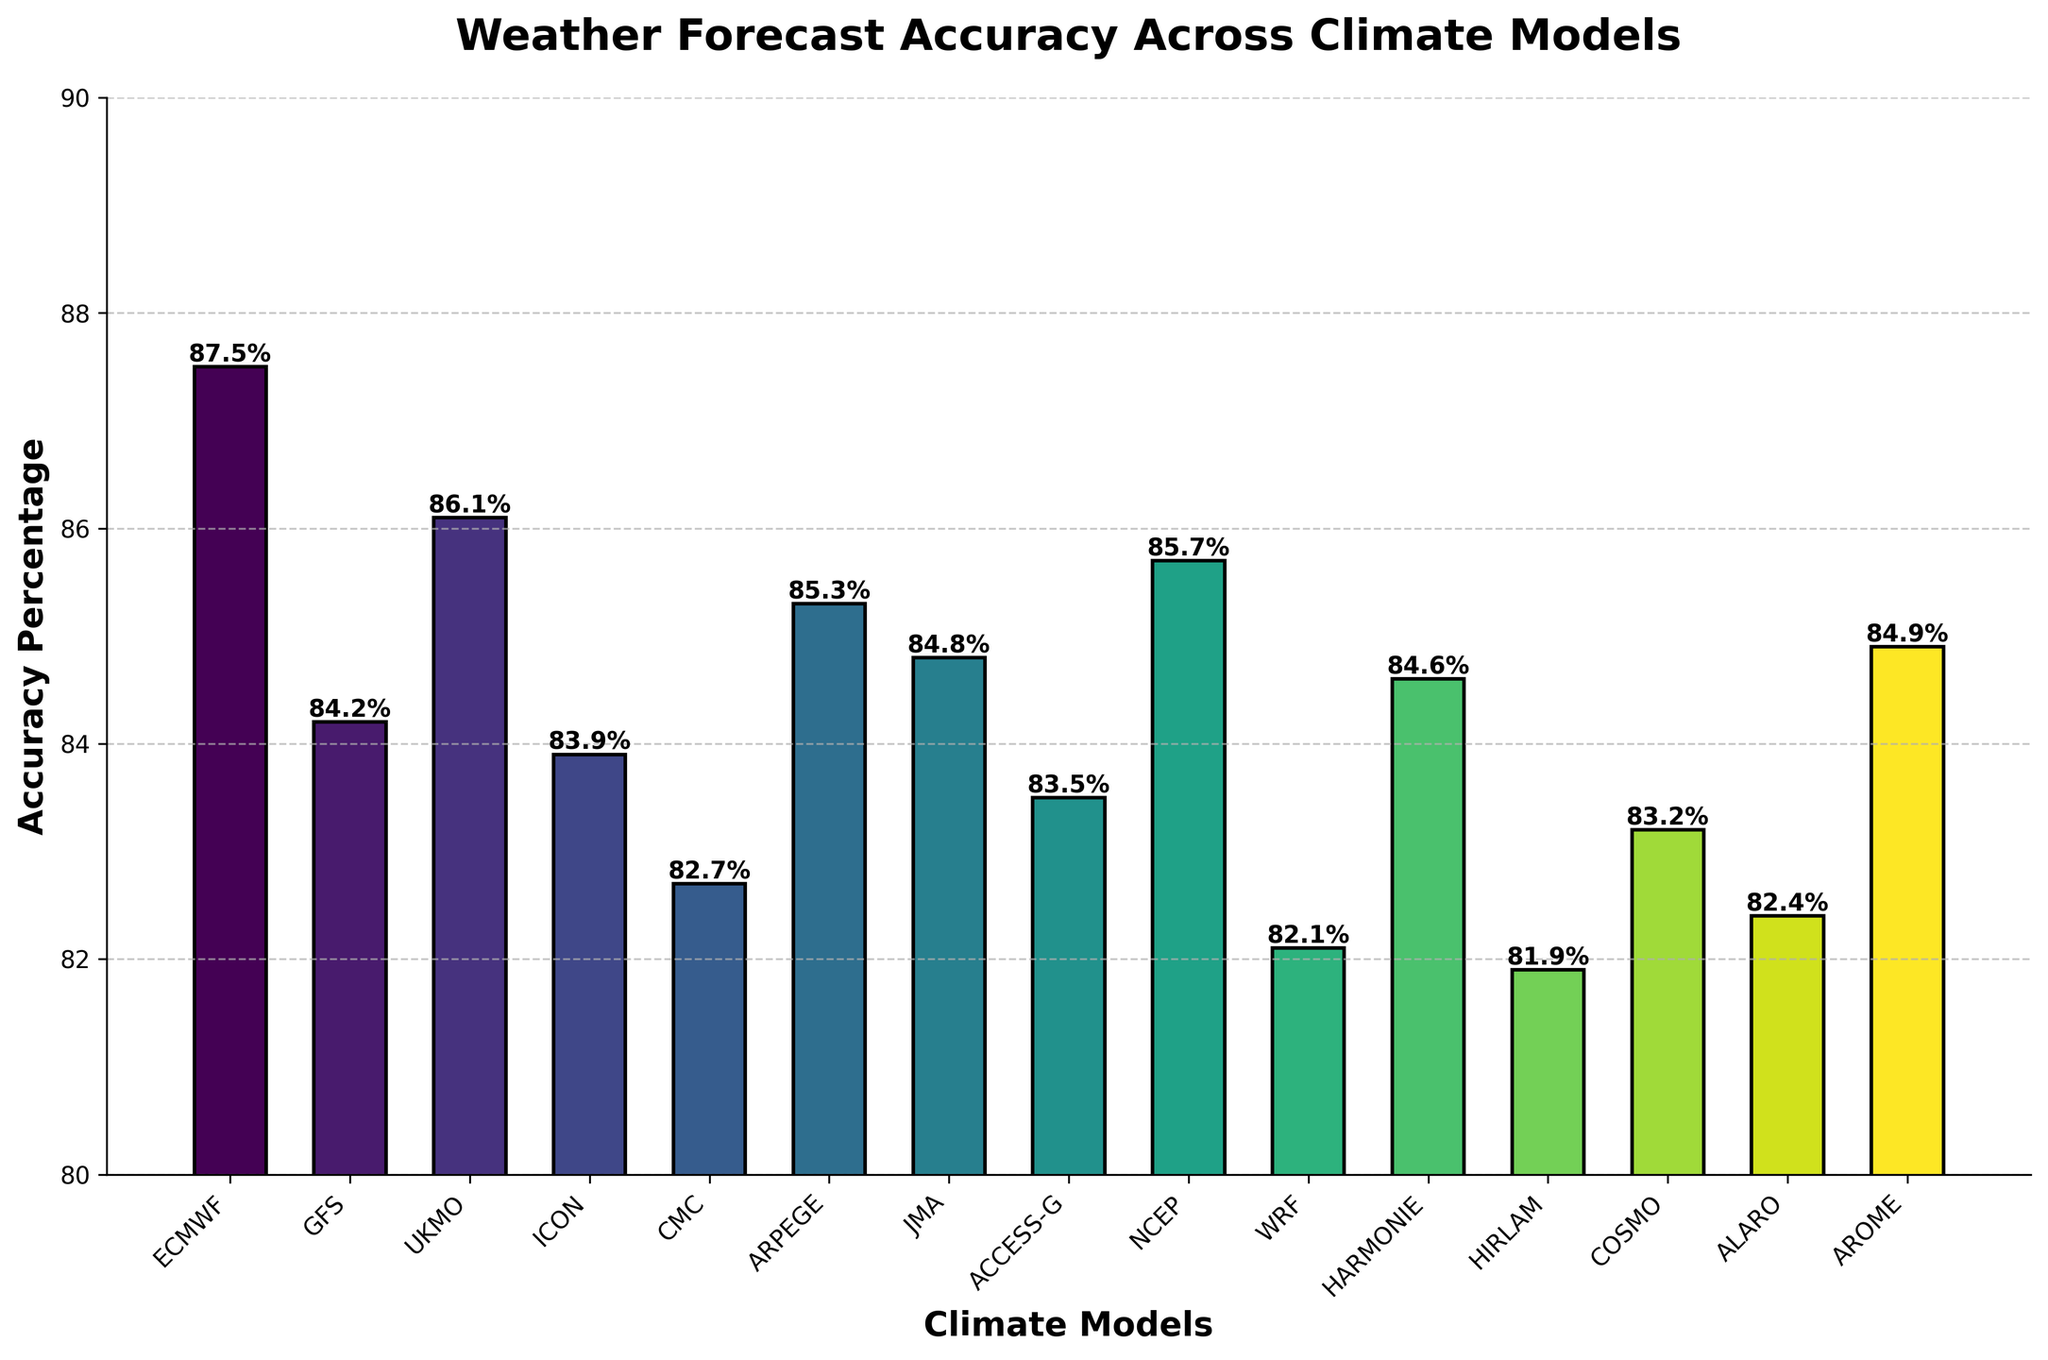Which climate model has the highest weather forecast accuracy? Identify the bar that reaches the highest point in the chart which represents the highest accuracy percentage. That model is ECMWF with 87.5%.
Answer: ECMWF Is the forecast accuracy of GFS higher or lower than ARPEGE? Compare the heights of the bars representing GFS and ARPEGE. GFS has an accuracy of 84.2%, while ARPEGE has 85.3%, hence ARPEGE is higher.
Answer: Lower What is the accuracy difference between the top-performing model and the lowest-performing model? ECMWF is the top-performing model with 87.5%. HIRLAM is the lowest-performing model with 81.9%. Subtract 81.9 from 87.5.
Answer: 5.6% Which models have an accuracy above 85%? Look at the height labels of the bars. Models with accuracy above 85% are ECMWF, UKMO, ARPEGE, NCEP, and AROME.
Answer: ECMWF, UKMO, ARPEGE, NCEP, AROME How does the accuracy of UKMO compare to JMA? Compare the heights of the UKMO and JMA bars. UKMO has an accuracy of 86.1%, and JMA has 84.8%. UKMO is higher.
Answer: Higher What is the average accuracy of the models? Sum all the accuracy values and divide by the total number of models (15). Sum: 1248.6, Average: 1248.6/15.
Answer: 83.24% List the models in decreasing order of accuracy. Look at the bar heights and their labels. The order from highest to lowest is ECMWF, UKMO, NCEP, ARPEGE, AROME, JMA, HARMONIE, GFS, ICON, ACCESS-G, COSMO, ALARO, CMC, WRF, and HIRLAM.
Answer: ECMWF, UKMO, NCEP, ARPEGE, AROME, JMA, HARMONIE, GFS, ICON, ACCESS-G, COSMO, ALARO, CMC, WRF, HIRLAM Are there any models with an accuracy of exactly 85%? Look at the bar heights and labels to see if any of them are equal to 85%. There are none at exactly 85%.
Answer: No What's the range of forecast accuracies among the models? The range is calculated by subtracting the smallest accuracy (HIRLAM, 81.9%) from the highest accuracy (ECMWF, 87.5%).
Answer: 5.6% 